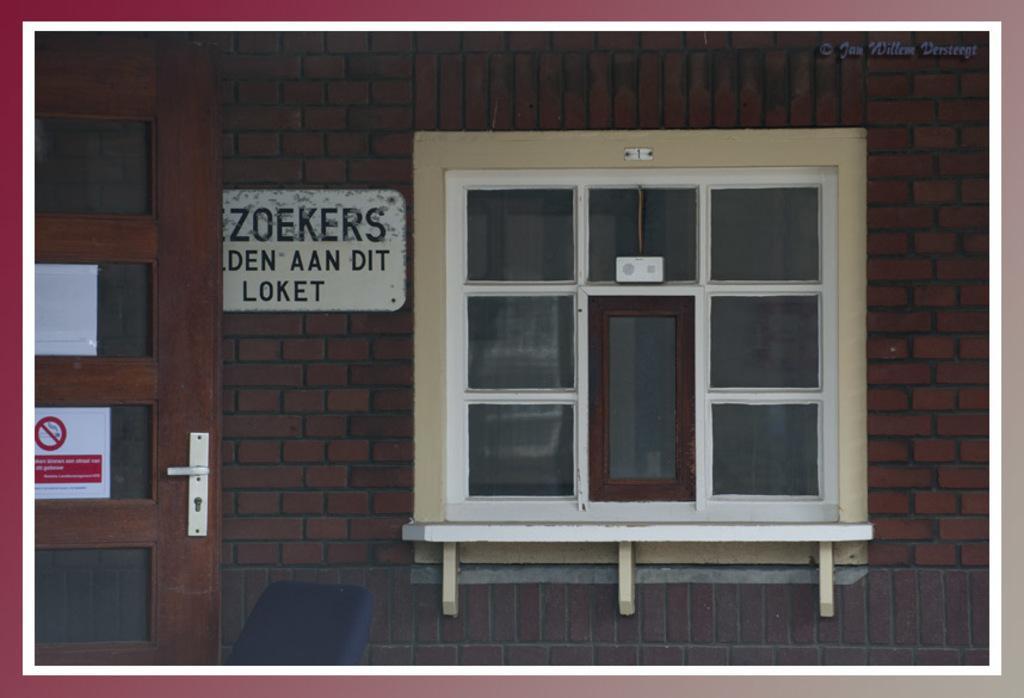Please provide a concise description of this image. As we can see in the image there is a brick wall, door, window and a poster. 